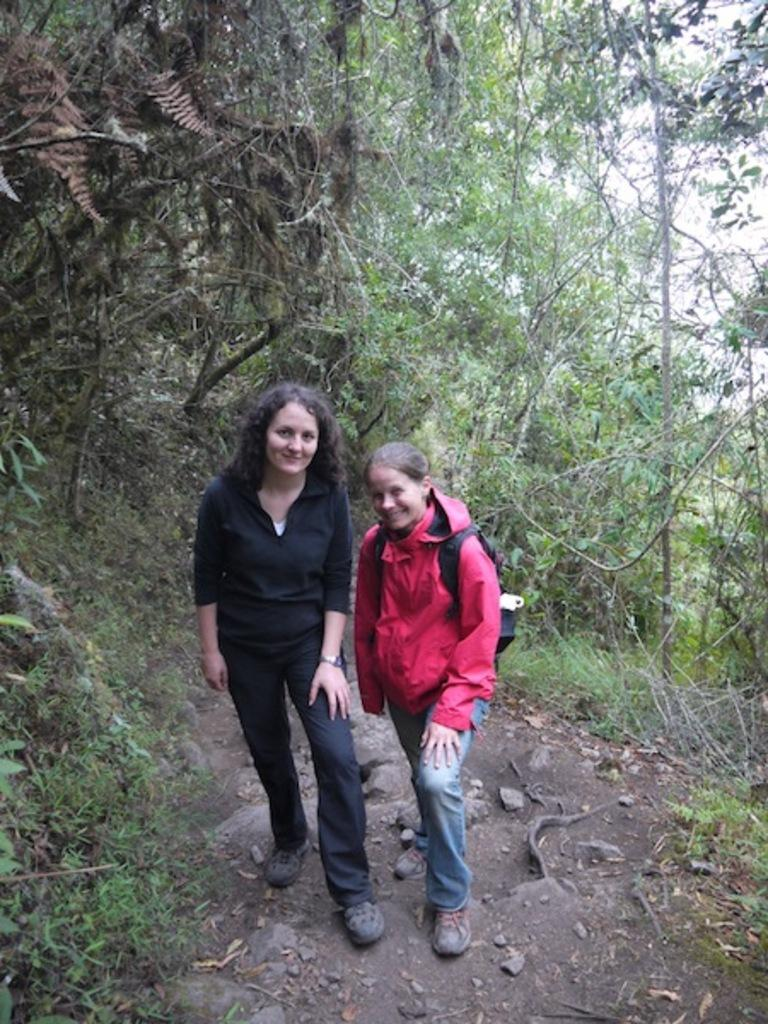How many people are in the image? There are two people standing in the image. What colors are the dresses worn by the people in the image? One person is wearing a pink dress, one person is wearing a black dress, and one person is wearing a blue dress. What can be seen in the background of the image? Trees and the sky are visible in the image. Can you tell me how many donkeys are present in the image? There are no donkeys present in the image. What type of shock can be seen affecting the person in the blue dress? There is no shock or any indication of a shock affecting any person in the image. 